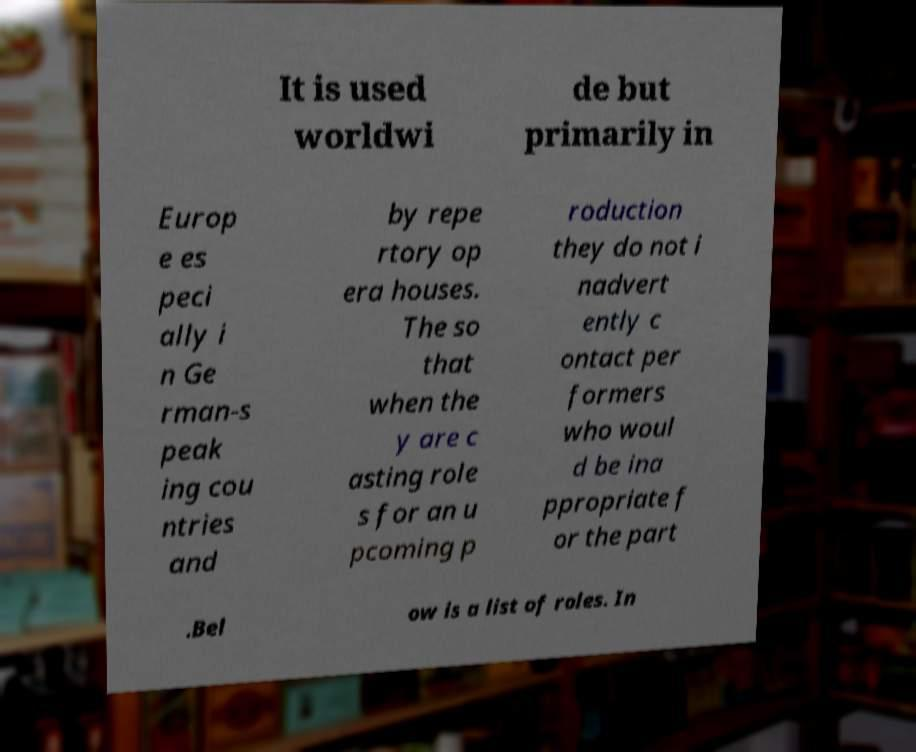Please identify and transcribe the text found in this image. It is used worldwi de but primarily in Europ e es peci ally i n Ge rman-s peak ing cou ntries and by repe rtory op era houses. The so that when the y are c asting role s for an u pcoming p roduction they do not i nadvert ently c ontact per formers who woul d be ina ppropriate f or the part .Bel ow is a list of roles. In 